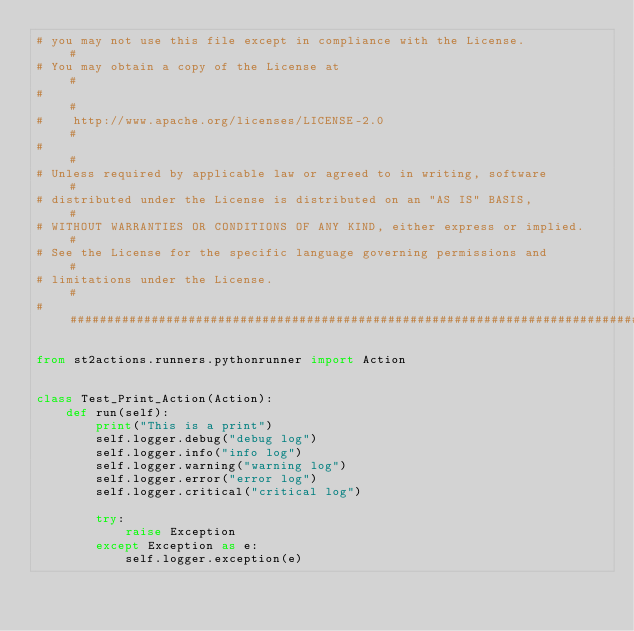<code> <loc_0><loc_0><loc_500><loc_500><_Python_># you may not use this file except in compliance with the License.           #
# You may obtain a copy of the License at                                    #
#                                                                            #
#    http://www.apache.org/licenses/LICENSE-2.0                              #
#                                                                            #
# Unless required by applicable law or agreed to in writing, software        #
# distributed under the License is distributed on an "AS IS" BASIS,          #
# WITHOUT WARRANTIES OR CONDITIONS OF ANY KIND, either express or implied.   #
# See the License for the specific language governing permissions and        #
# limitations under the License.                                             #
##############################################################################

from st2actions.runners.pythonrunner import Action


class Test_Print_Action(Action):
    def run(self):
        print("This is a print")
        self.logger.debug("debug log")
        self.logger.info("info log")
        self.logger.warning("warning log")
        self.logger.error("error log")
        self.logger.critical("critical log")

        try:
            raise Exception
        except Exception as e:
            self.logger.exception(e)
</code> 